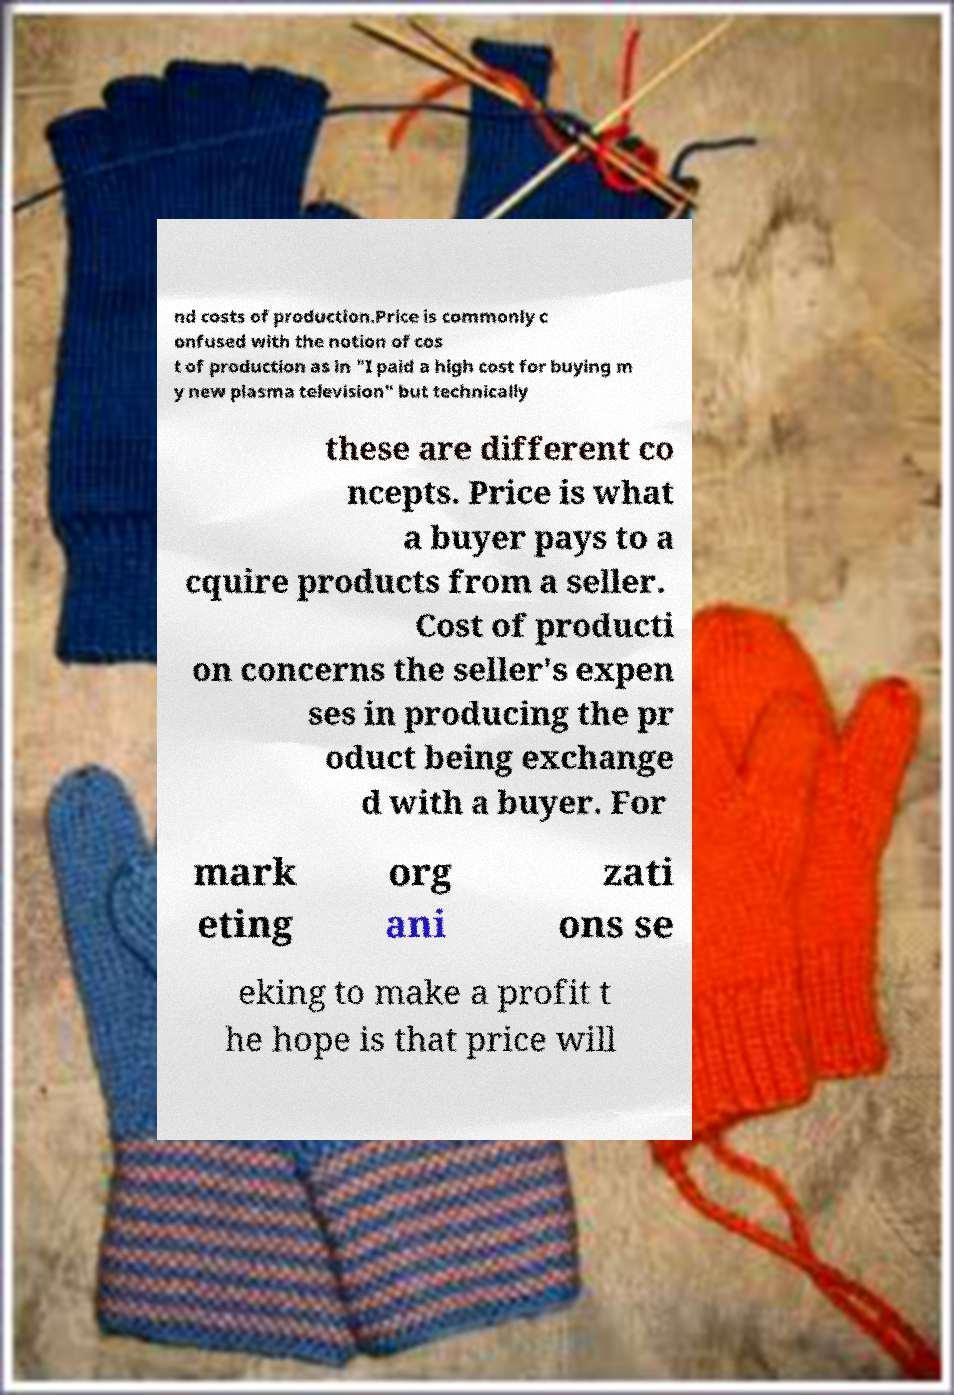For documentation purposes, I need the text within this image transcribed. Could you provide that? nd costs of production.Price is commonly c onfused with the notion of cos t of production as in "I paid a high cost for buying m y new plasma television" but technically these are different co ncepts. Price is what a buyer pays to a cquire products from a seller. Cost of producti on concerns the seller's expen ses in producing the pr oduct being exchange d with a buyer. For mark eting org ani zati ons se eking to make a profit t he hope is that price will 